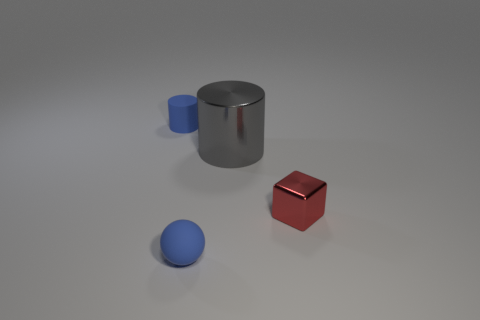What shapes can you identify in the image? In the image, there are three distinct shapes: a cylinder, a cube, and a sphere. 